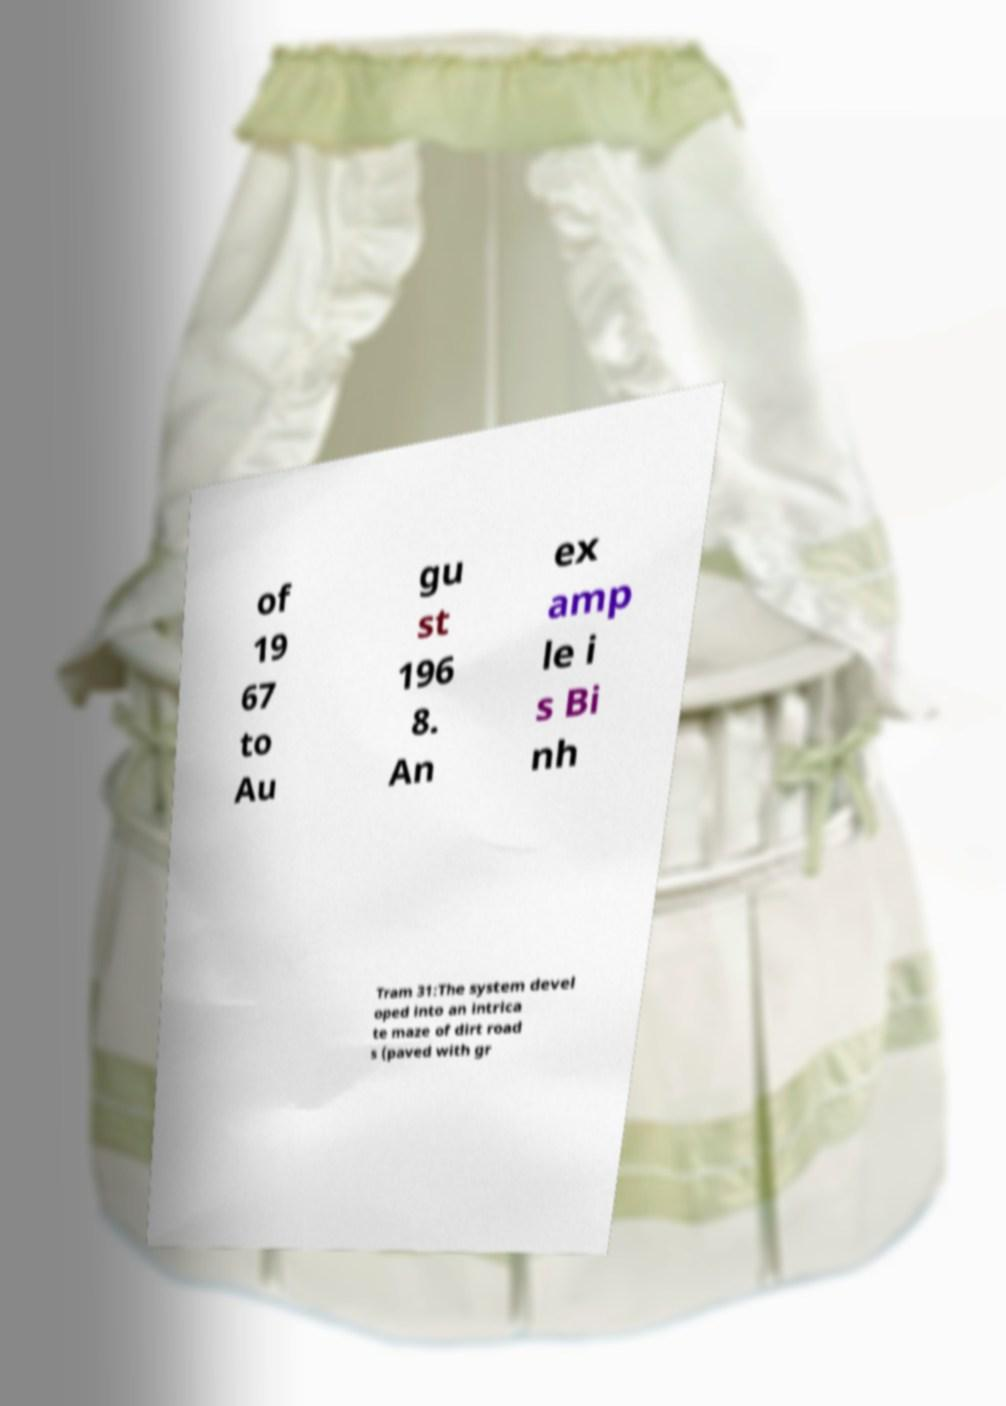What messages or text are displayed in this image? I need them in a readable, typed format. of 19 67 to Au gu st 196 8. An ex amp le i s Bi nh Tram 31:The system devel oped into an intrica te maze of dirt road s (paved with gr 